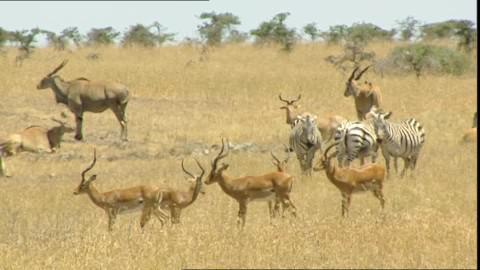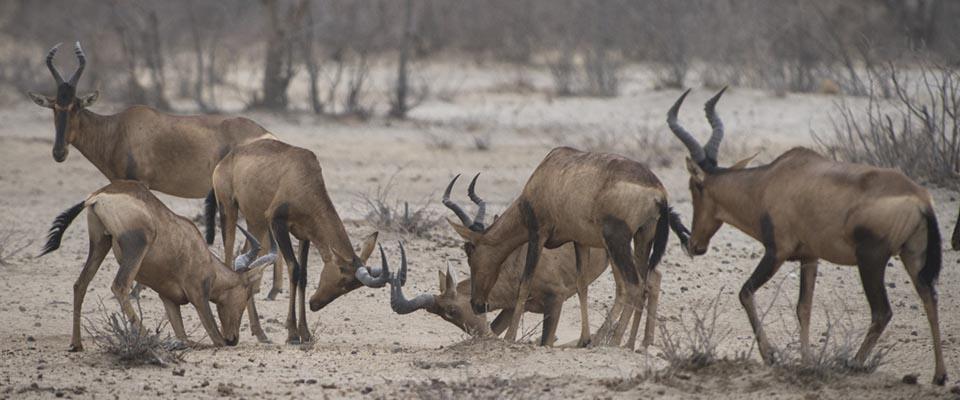The first image is the image on the left, the second image is the image on the right. Considering the images on both sides, is "One of the images contains no more than four antelopes" valid? Answer yes or no. No. The first image is the image on the left, the second image is the image on the right. For the images displayed, is the sentence "All the horned animals in one image have their rears turned to the camera." factually correct? Answer yes or no. No. 